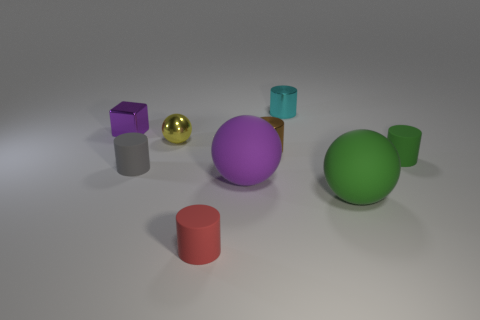Subtract all green balls. How many balls are left? 2 Subtract all metallic cylinders. How many cylinders are left? 3 Subtract 1 cubes. How many cubes are left? 0 Subtract all blocks. How many objects are left? 8 Subtract all blue cylinders. Subtract all cyan balls. How many cylinders are left? 5 Subtract all gray blocks. How many yellow cylinders are left? 0 Subtract all tiny red metal cylinders. Subtract all tiny gray matte things. How many objects are left? 8 Add 4 brown cylinders. How many brown cylinders are left? 5 Add 1 small matte cylinders. How many small matte cylinders exist? 4 Subtract 1 gray cylinders. How many objects are left? 8 